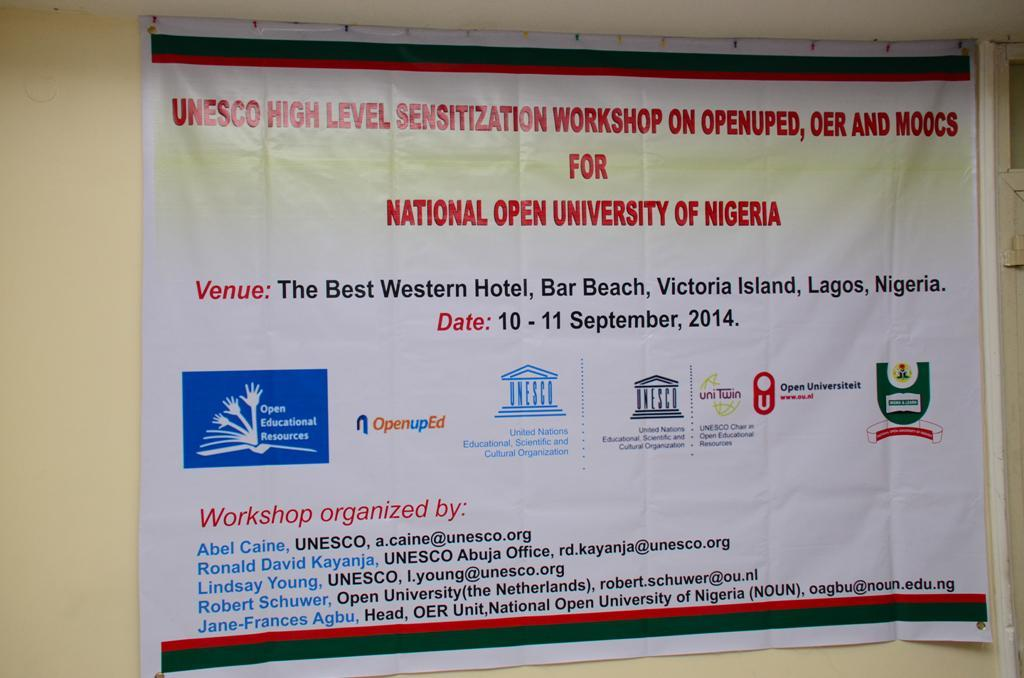<image>
Summarize the visual content of the image. A banner from the National Open University of Nigeria advertising an upcoming workshop. 